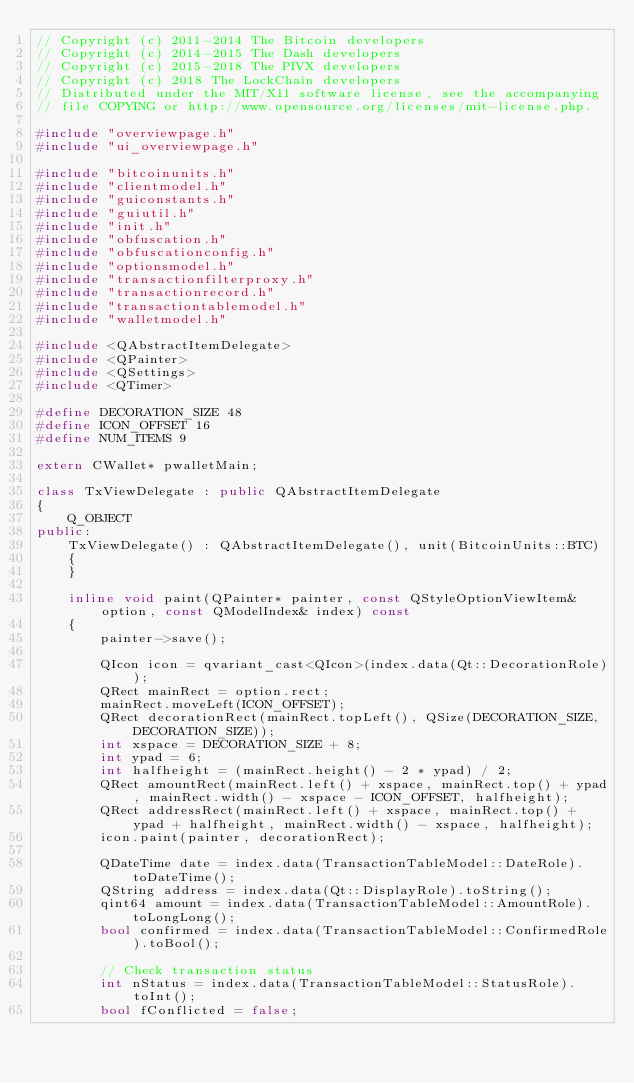<code> <loc_0><loc_0><loc_500><loc_500><_C++_>// Copyright (c) 2011-2014 The Bitcoin developers
// Copyright (c) 2014-2015 The Dash developers
// Copyright (c) 2015-2018 The PIVX developers
// Copyright (c) 2018 The LockChain developers
// Distributed under the MIT/X11 software license, see the accompanying
// file COPYING or http://www.opensource.org/licenses/mit-license.php.

#include "overviewpage.h"
#include "ui_overviewpage.h"

#include "bitcoinunits.h"
#include "clientmodel.h"
#include "guiconstants.h"
#include "guiutil.h"
#include "init.h"
#include "obfuscation.h"
#include "obfuscationconfig.h"
#include "optionsmodel.h"
#include "transactionfilterproxy.h"
#include "transactionrecord.h"
#include "transactiontablemodel.h"
#include "walletmodel.h"

#include <QAbstractItemDelegate>
#include <QPainter>
#include <QSettings>
#include <QTimer>

#define DECORATION_SIZE 48
#define ICON_OFFSET 16
#define NUM_ITEMS 9

extern CWallet* pwalletMain;

class TxViewDelegate : public QAbstractItemDelegate
{
    Q_OBJECT
public:
    TxViewDelegate() : QAbstractItemDelegate(), unit(BitcoinUnits::BTC)
    {
    }

    inline void paint(QPainter* painter, const QStyleOptionViewItem& option, const QModelIndex& index) const
    {
        painter->save();

        QIcon icon = qvariant_cast<QIcon>(index.data(Qt::DecorationRole));
        QRect mainRect = option.rect;
        mainRect.moveLeft(ICON_OFFSET);
        QRect decorationRect(mainRect.topLeft(), QSize(DECORATION_SIZE, DECORATION_SIZE));
        int xspace = DECORATION_SIZE + 8;
        int ypad = 6;
        int halfheight = (mainRect.height() - 2 * ypad) / 2;
        QRect amountRect(mainRect.left() + xspace, mainRect.top() + ypad, mainRect.width() - xspace - ICON_OFFSET, halfheight);
        QRect addressRect(mainRect.left() + xspace, mainRect.top() + ypad + halfheight, mainRect.width() - xspace, halfheight);
        icon.paint(painter, decorationRect);

        QDateTime date = index.data(TransactionTableModel::DateRole).toDateTime();
        QString address = index.data(Qt::DisplayRole).toString();
        qint64 amount = index.data(TransactionTableModel::AmountRole).toLongLong();
        bool confirmed = index.data(TransactionTableModel::ConfirmedRole).toBool();

        // Check transaction status
        int nStatus = index.data(TransactionTableModel::StatusRole).toInt();
        bool fConflicted = false;</code> 